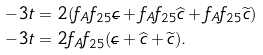<formula> <loc_0><loc_0><loc_500><loc_500>- 3 t & = 2 ( f _ { A } f _ { 2 5 } \overline { c } + f _ { A } f _ { 2 5 } \widehat { c } + f _ { A } f _ { 2 5 } \widetilde { c } ) \\ - 3 t & = 2 f _ { A } f _ { 2 5 } ( \overline { c } + \widehat { c } + \widetilde { c } ) .</formula> 